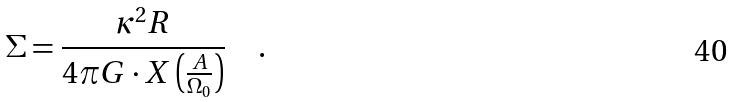<formula> <loc_0><loc_0><loc_500><loc_500>\Sigma = \frac { \kappa ^ { 2 } R } { 4 \pi G \cdot X \left ( \frac { A } { \Omega _ { 0 } } \right ) } \quad .</formula> 